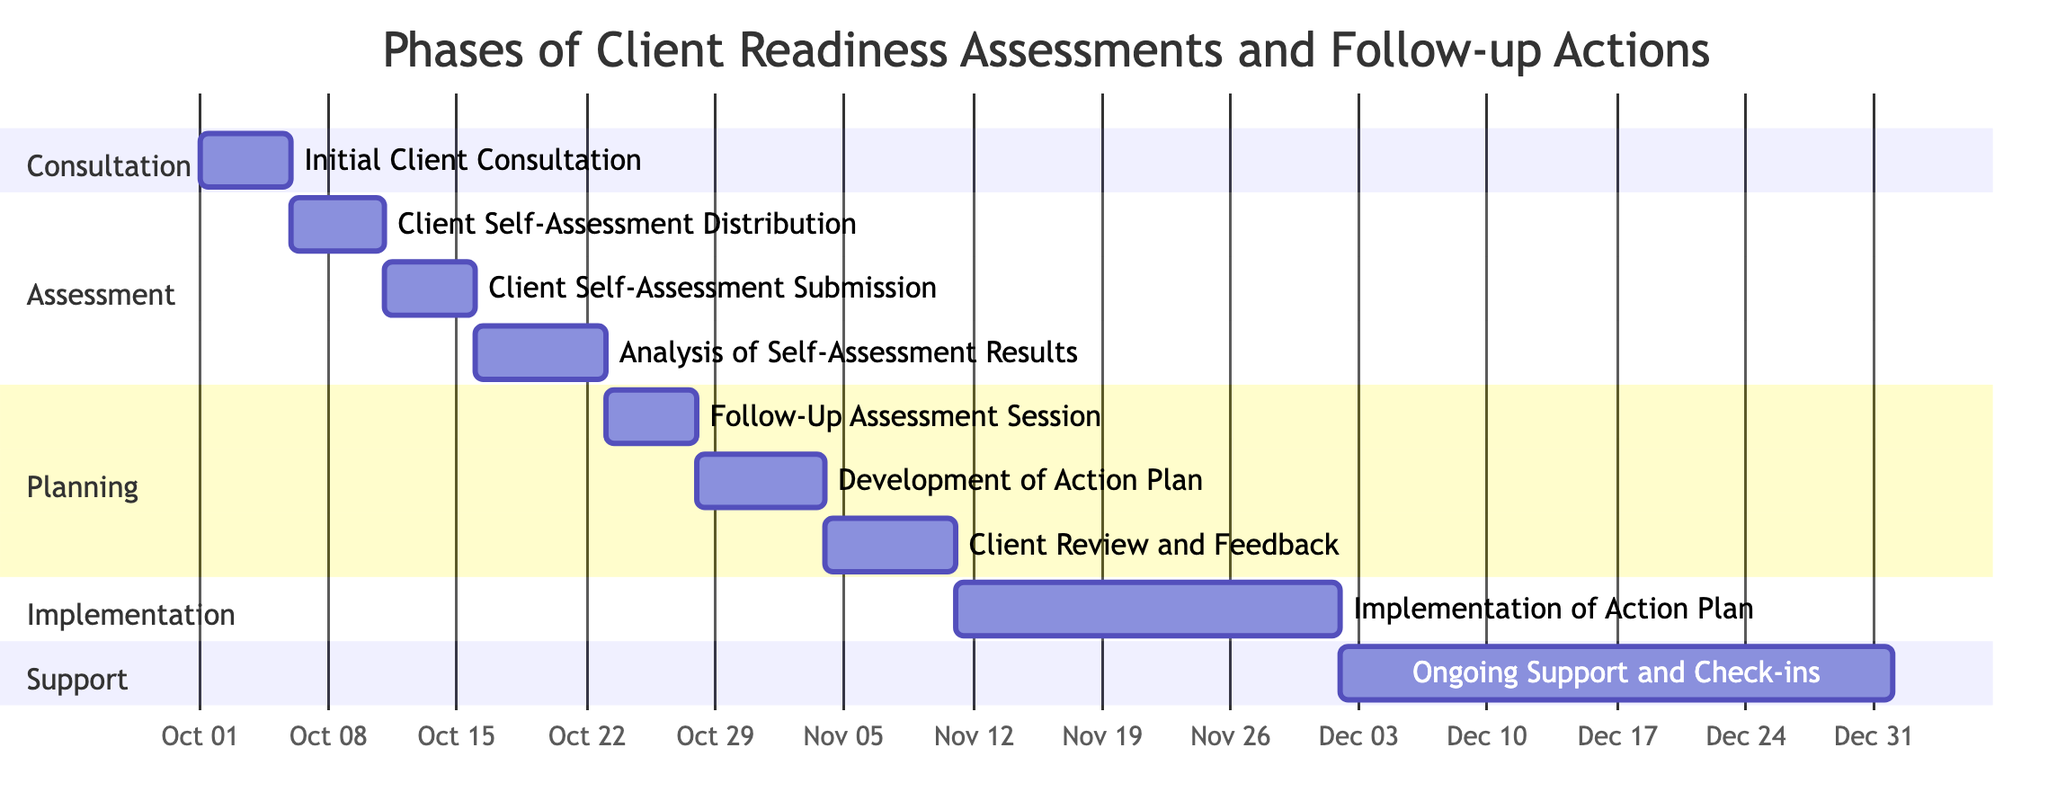what is the duration of the 'Implementation of Action Plan'? The 'Implementation of Action Plan' phase spans from November 11, 2023, to December 1, 2023. Therefore, the duration is calculated by counting the total days within this date range, which is 21 days.
Answer: 21 days when does the 'Client Self-Assessment Submission' start? According to the Gantt chart, the 'Client Self-Assessment Submission' phase starts on October 11, 2023. This is the earliest date shown for that specific phase.
Answer: October 11, 2023 how many phases are there in the 'Support' section? The 'Support' section consists of one phase titled 'Ongoing Support and Check-ins'. The count of phases in that section shows that there is only one phase listed.
Answer: 1 which phase follows 'Analysis of Self-Assessment Results'? The phase that directly follows 'Analysis of Self-Assessment Results' is 'Follow-Up Assessment Session'. In examining the order of phases, this is the immediate next phase occurring after analysis.
Answer: Follow-Up Assessment Session what is the total number of days for the 'Development of Action Plan'? The 'Development of Action Plan' runs from October 28, 2023, to November 3, 2023. The number of days between these two dates is 7 days, so this is the total duration for that phase.
Answer: 7 days at what date does the 'Client Review and Feedback' end? The 'Client Review and Feedback' phase ends on November 10, 2023. This is indicated by the end date assigned to this particular phase in the Gantt chart.
Answer: November 10, 2023 what is the main task within the 'Planning' section? The main tasks within the 'Planning' section are 'Follow-Up Assessment Session', 'Development of Action Plan', and 'Client Review and Feedback'. Therefore, all three tasks are categorized within that section.
Answer: Follow-Up Assessment Session, Development of Action Plan, Client Review and Feedback which phase has the longest duration? The phase with the longest duration is 'Ongoing Support and Check-ins', lasting 30 days from December 2, 2023, to January 1, 2024. This is the longest duration shown across all phases in the Gantt chart.
Answer: Ongoing Support and Check-ins what date does the 'Client Self-Assessment Distribution' begin? The 'Client Self-Assessment Distribution' begins on October 6, 2023, as marked in the timeline of the Gantt chart. This date is clearly specified for that phase.
Answer: October 6, 2023 